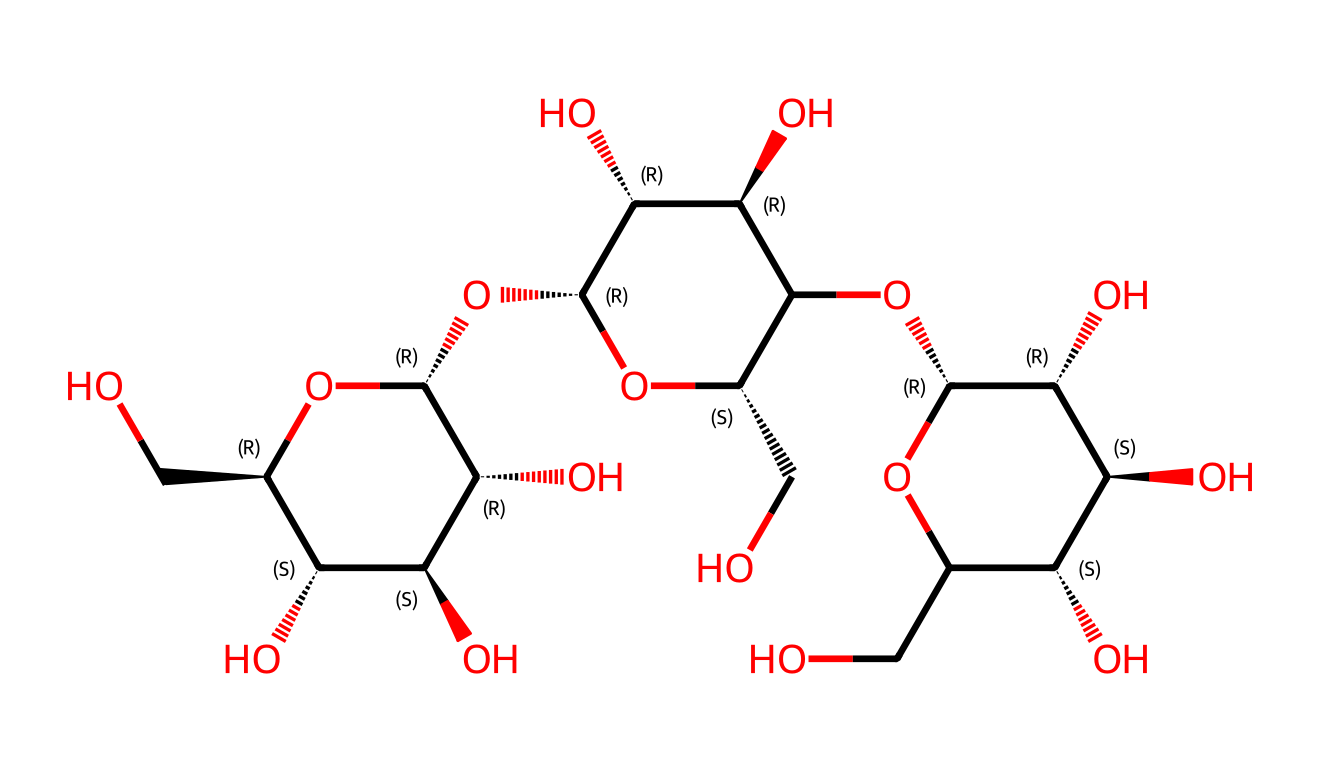What is the molecular formula of the structure represented by the SMILES? By analyzing the SMILES, we can identify the number of carbon (C), hydrogen (H), and oxygen (O) atoms present in the structure. Counting each atom in the structure yields a molecular formula of C6H10O5.
Answer: C6H10O5 How many hydroxyl groups are present in the chemical structure? In the visual representation of the chemical, each hydroxyl group is represented by the [OH] notation in the SMILES. Identifying these within the structure reveals there are five hydroxyl groups.
Answer: five What type of structural features are primarily associated with cellulose nanofibers? The structure exhibits multiple hydroxyl (-OH) groups and an intricate arrangement of glucose units, characteristic of polysaccharides like cellulose. These features enable hydrogen bonding and structural stability, aligning with cellulose's known fibrous nature.
Answer: polysaccharides How many stereogenic centers are found in the chemical structure? Inspecting the structure for stereogenic centers involves identifying carbon atoms bonded to four different substituents. The structure contains four stereogenic centers, which are also indicated by the stereochemistry designations in the SMILES.
Answer: four What is the primary functionality that allows cellulose to facilitate targeted drug delivery? Cellulose's extensive hydroxyl groups provide sites for chemical modifications and functionalization, facilitating targeted drug delivery by enhancing solubility, stability, or binding to specific receptors.
Answer: hydroxyl groups 